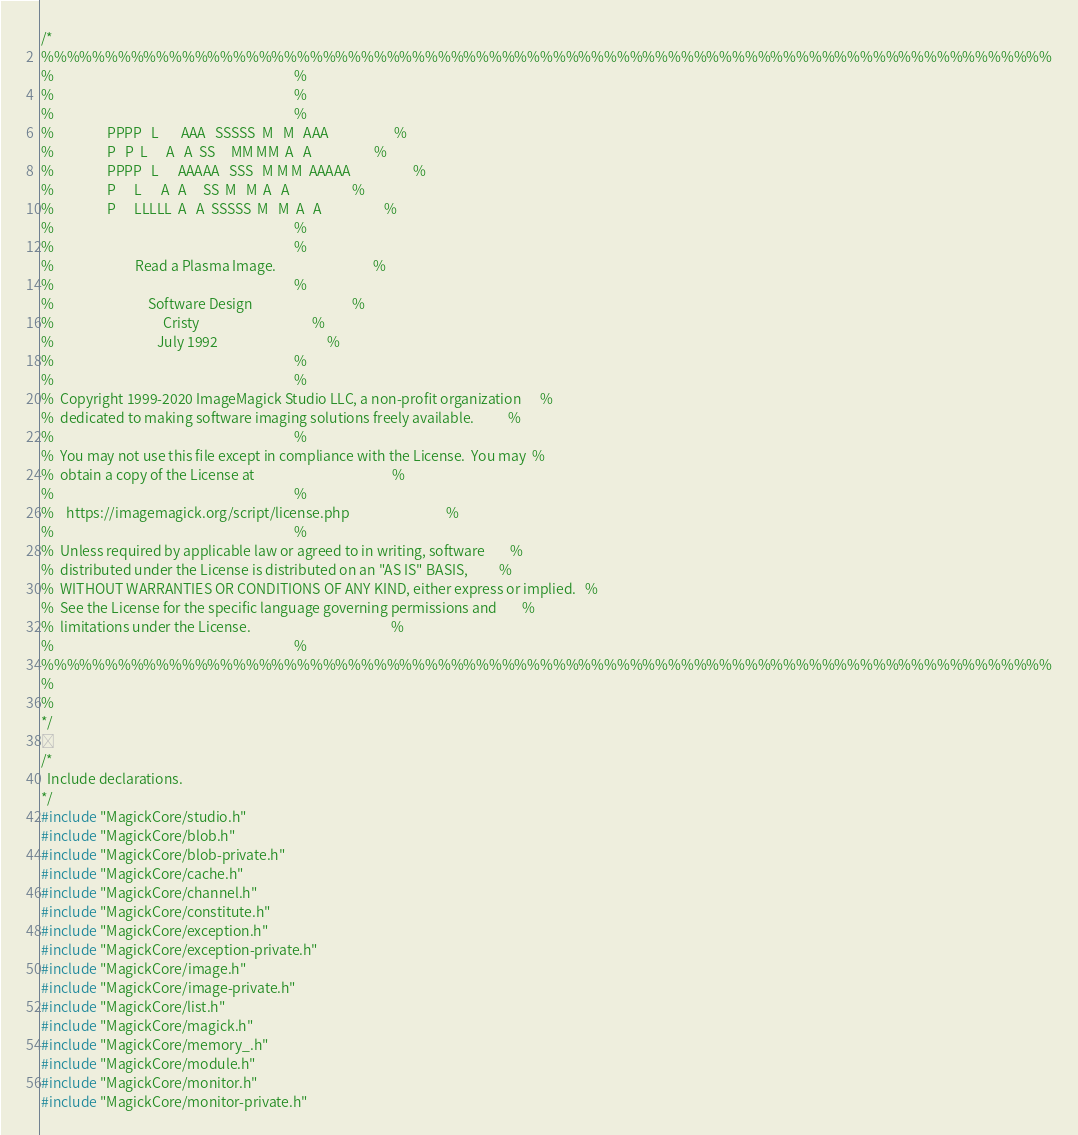Convert code to text. <code><loc_0><loc_0><loc_500><loc_500><_C_>/*
%%%%%%%%%%%%%%%%%%%%%%%%%%%%%%%%%%%%%%%%%%%%%%%%%%%%%%%%%%%%%%%%%%%%%%%%%%%%%%%
%                                                                             %
%                                                                             %
%                                                                             %
%                 PPPP   L       AAA   SSSSS  M   M   AAA                     %
%                 P   P  L      A   A  SS     MM MM  A   A                    %
%                 PPPP   L      AAAAA   SSS   M M M  AAAAA                    %
%                 P      L      A   A     SS  M   M  A   A                    %
%                 P      LLLLL  A   A  SSSSS  M   M  A   A                    %
%                                                                             %
%                                                                             %
%                          Read a Plasma Image.                               %
%                                                                             %
%                              Software Design                                %
%                                   Cristy                                    %
%                                 July 1992                                   %
%                                                                             %
%                                                                             %
%  Copyright 1999-2020 ImageMagick Studio LLC, a non-profit organization      %
%  dedicated to making software imaging solutions freely available.           %
%                                                                             %
%  You may not use this file except in compliance with the License.  You may  %
%  obtain a copy of the License at                                            %
%                                                                             %
%    https://imagemagick.org/script/license.php                               %
%                                                                             %
%  Unless required by applicable law or agreed to in writing, software        %
%  distributed under the License is distributed on an "AS IS" BASIS,          %
%  WITHOUT WARRANTIES OR CONDITIONS OF ANY KIND, either express or implied.   %
%  See the License for the specific language governing permissions and        %
%  limitations under the License.                                             %
%                                                                             %
%%%%%%%%%%%%%%%%%%%%%%%%%%%%%%%%%%%%%%%%%%%%%%%%%%%%%%%%%%%%%%%%%%%%%%%%%%%%%%%
%
%
*/

/*
  Include declarations.
*/
#include "MagickCore/studio.h"
#include "MagickCore/blob.h"
#include "MagickCore/blob-private.h"
#include "MagickCore/cache.h"
#include "MagickCore/channel.h"
#include "MagickCore/constitute.h"
#include "MagickCore/exception.h"
#include "MagickCore/exception-private.h"
#include "MagickCore/image.h"
#include "MagickCore/image-private.h"
#include "MagickCore/list.h"
#include "MagickCore/magick.h"
#include "MagickCore/memory_.h"
#include "MagickCore/module.h"
#include "MagickCore/monitor.h"
#include "MagickCore/monitor-private.h"</code> 